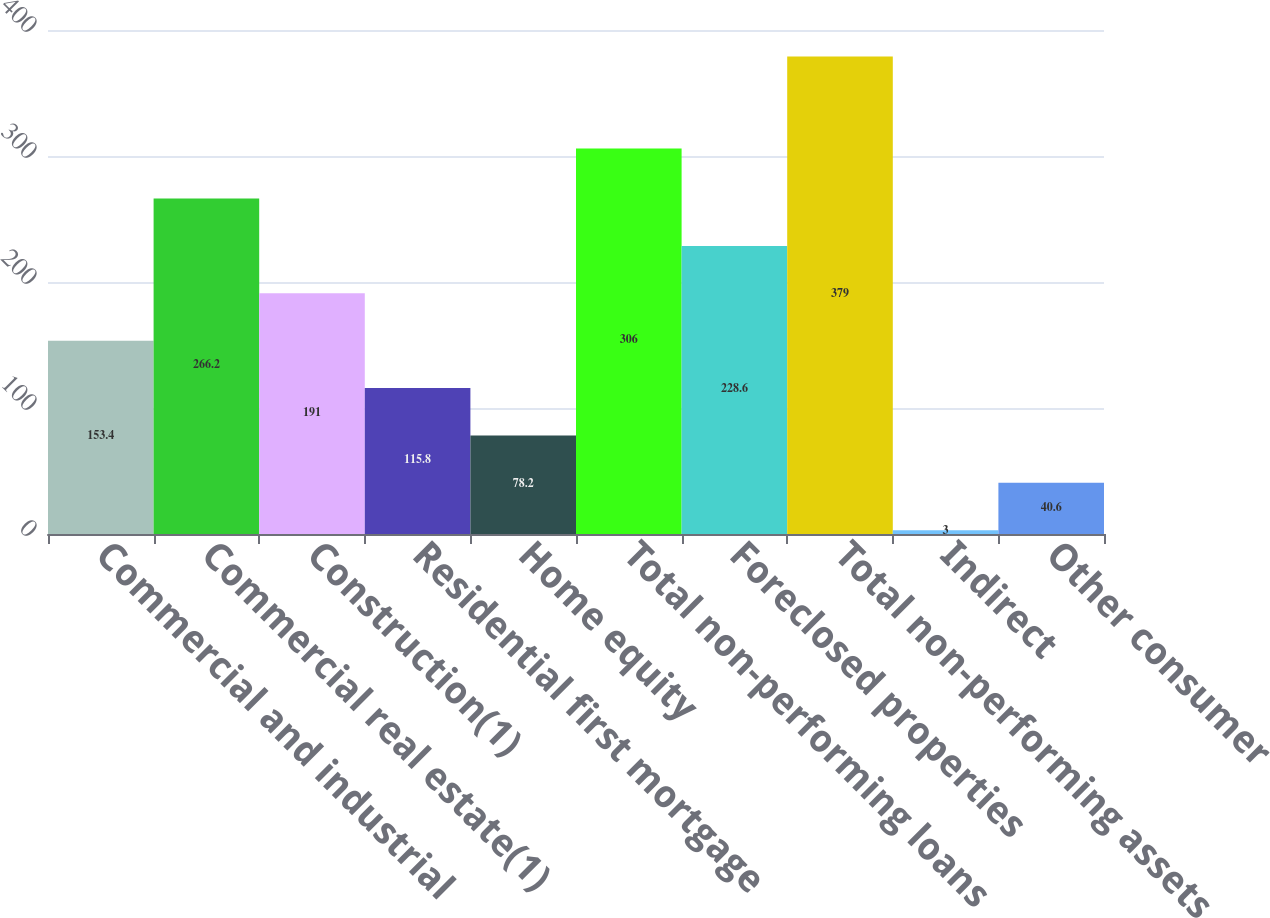<chart> <loc_0><loc_0><loc_500><loc_500><bar_chart><fcel>Commercial and industrial<fcel>Commercial real estate(1)<fcel>Construction(1)<fcel>Residential first mortgage<fcel>Home equity<fcel>Total non-performing loans<fcel>Foreclosed properties<fcel>Total non-performing assets<fcel>Indirect<fcel>Other consumer<nl><fcel>153.4<fcel>266.2<fcel>191<fcel>115.8<fcel>78.2<fcel>306<fcel>228.6<fcel>379<fcel>3<fcel>40.6<nl></chart> 